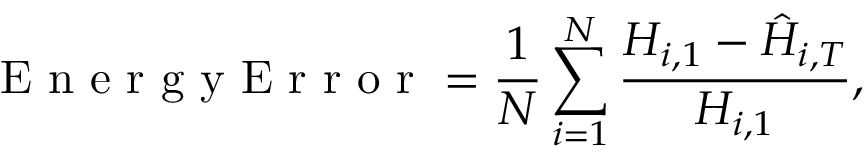<formula> <loc_0><loc_0><loc_500><loc_500>E n e r g y E r r o r = \frac { 1 } { N } \sum _ { i = 1 } ^ { N } \frac { H _ { i , 1 } - \hat { H } _ { i , T } } { H _ { i , 1 } } ,</formula> 